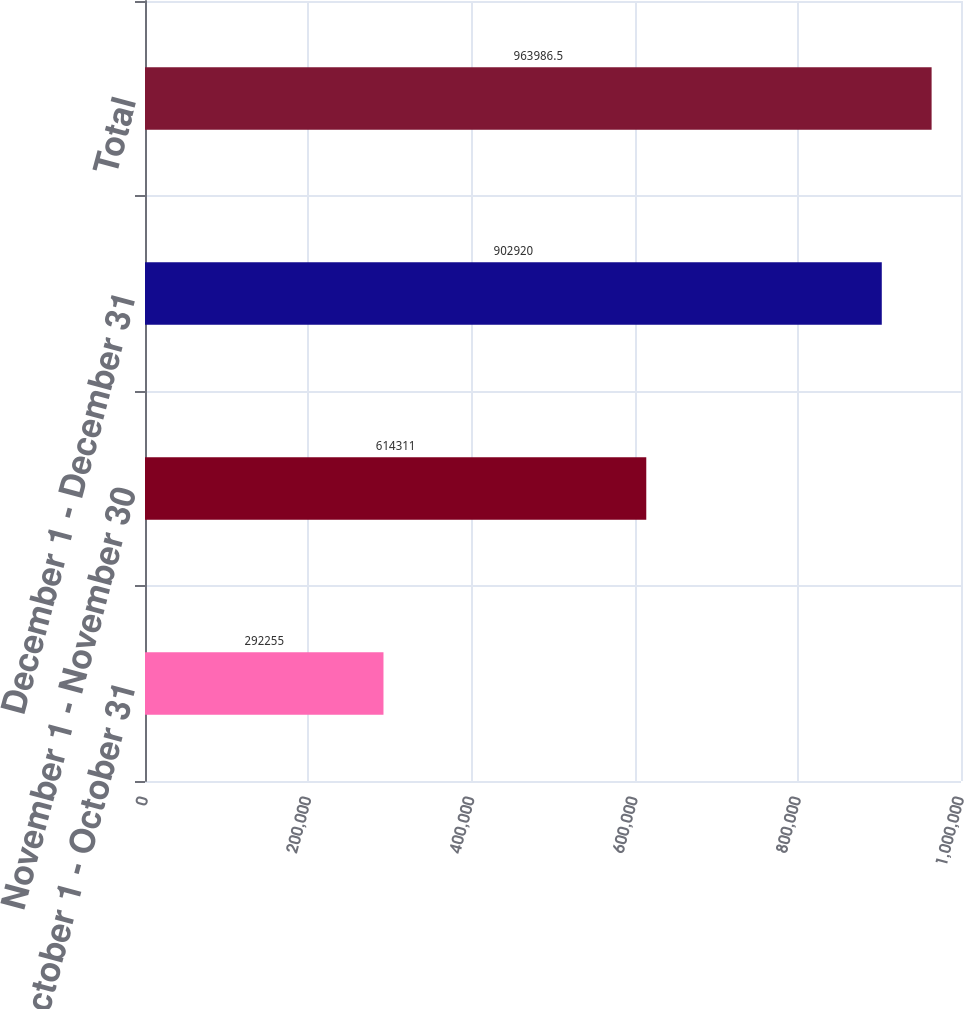Convert chart to OTSL. <chart><loc_0><loc_0><loc_500><loc_500><bar_chart><fcel>October 1 - October 31<fcel>November 1 - November 30<fcel>December 1 - December 31<fcel>Total<nl><fcel>292255<fcel>614311<fcel>902920<fcel>963986<nl></chart> 